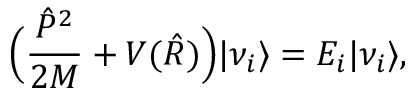Convert formula to latex. <formula><loc_0><loc_0><loc_500><loc_500>\left ( \frac { \hat { P } ^ { 2 } } { 2 M } + V ( \hat { R } ) \right ) | \nu _ { i } \rangle = E _ { i } | \nu _ { i } \rangle ,</formula> 